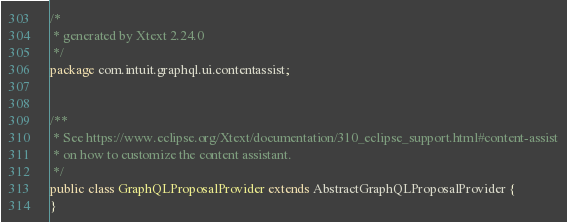Convert code to text. <code><loc_0><loc_0><loc_500><loc_500><_Java_>/*
 * generated by Xtext 2.24.0
 */
package com.intuit.graphql.ui.contentassist;


/**
 * See https://www.eclipse.org/Xtext/documentation/310_eclipse_support.html#content-assist
 * on how to customize the content assistant.
 */
public class GraphQLProposalProvider extends AbstractGraphQLProposalProvider {
}
</code> 